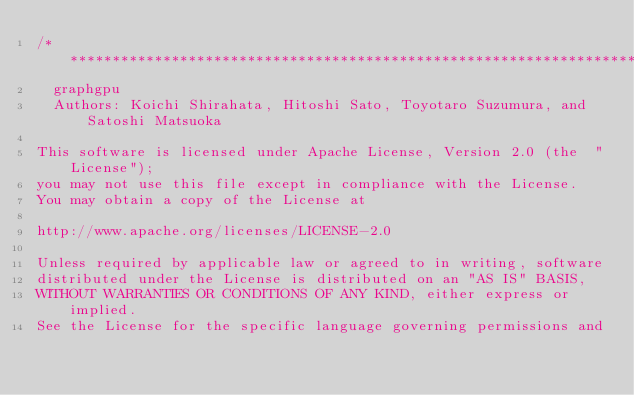<code> <loc_0><loc_0><loc_500><loc_500><_Cuda_>/***********************************************************************
 	graphgpu
	Authors: Koichi Shirahata, Hitoshi Sato, Toyotaro Suzumura, and Satoshi Matsuoka

This software is licensed under Apache License, Version 2.0 (the  "License");
you may not use this file except in compliance with the License.
You may obtain a copy of the License at

http://www.apache.org/licenses/LICENSE-2.0

Unless required by applicable law or agreed to in writing, software
distributed under the License is distributed on an "AS IS" BASIS,
WITHOUT WARRANTIES OR CONDITIONS OF ANY KIND, either express or implied.
See the License for the specific language governing permissions and</code> 